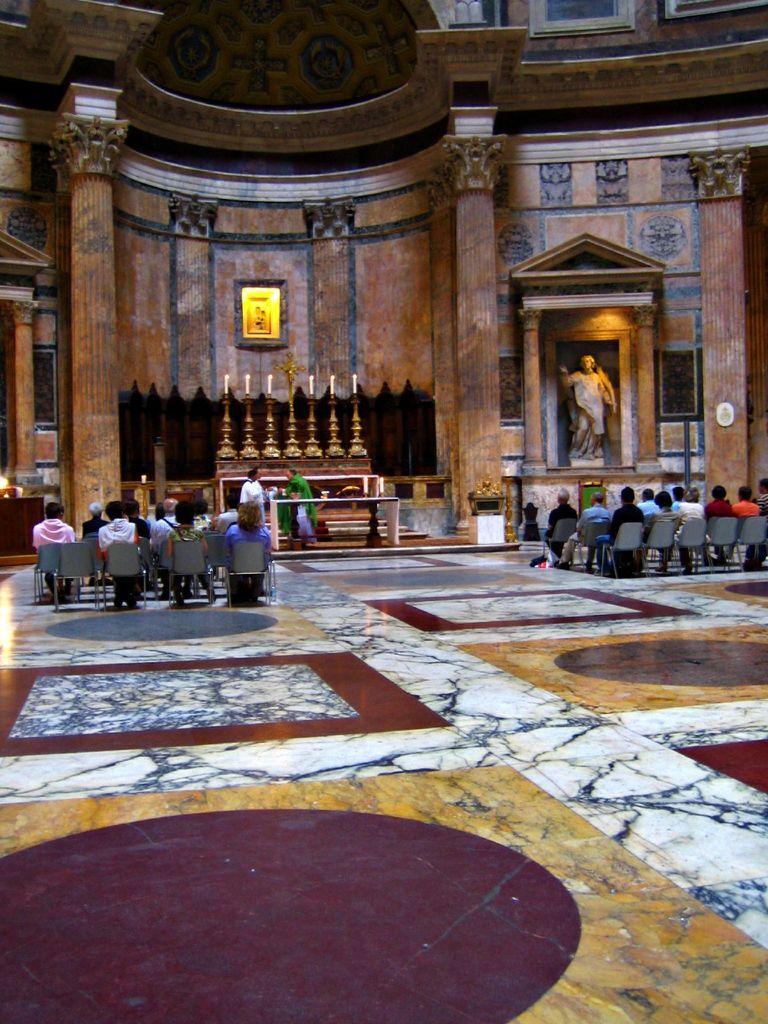Can you describe this image briefly? In this image we can see an inside view of a building. In the center of the image we can see some persons sitting on chairs, some persons are standing, a group of objects are placed on the table. In the background, we can see statues, candles, a cross, pillars and dome lights. 